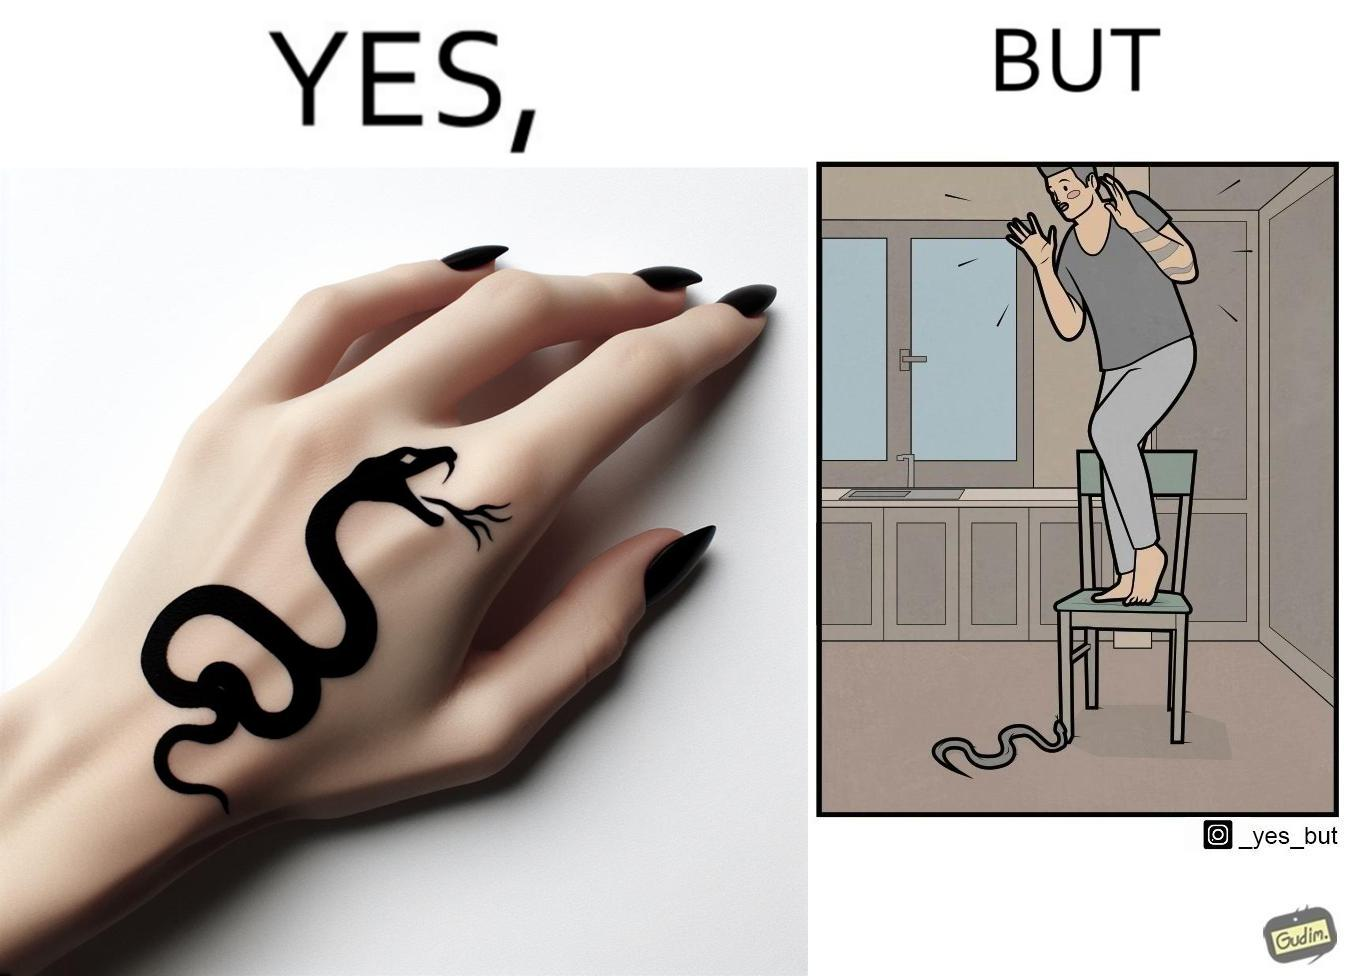What do you see in each half of this image? In the left part of the image: a tattoo of a snake with its mouth wide open on someone's hand In the right part of the image: a person standing on a chair trying save himself from the attack of snake and the snake is probably trying to climb up the chair 